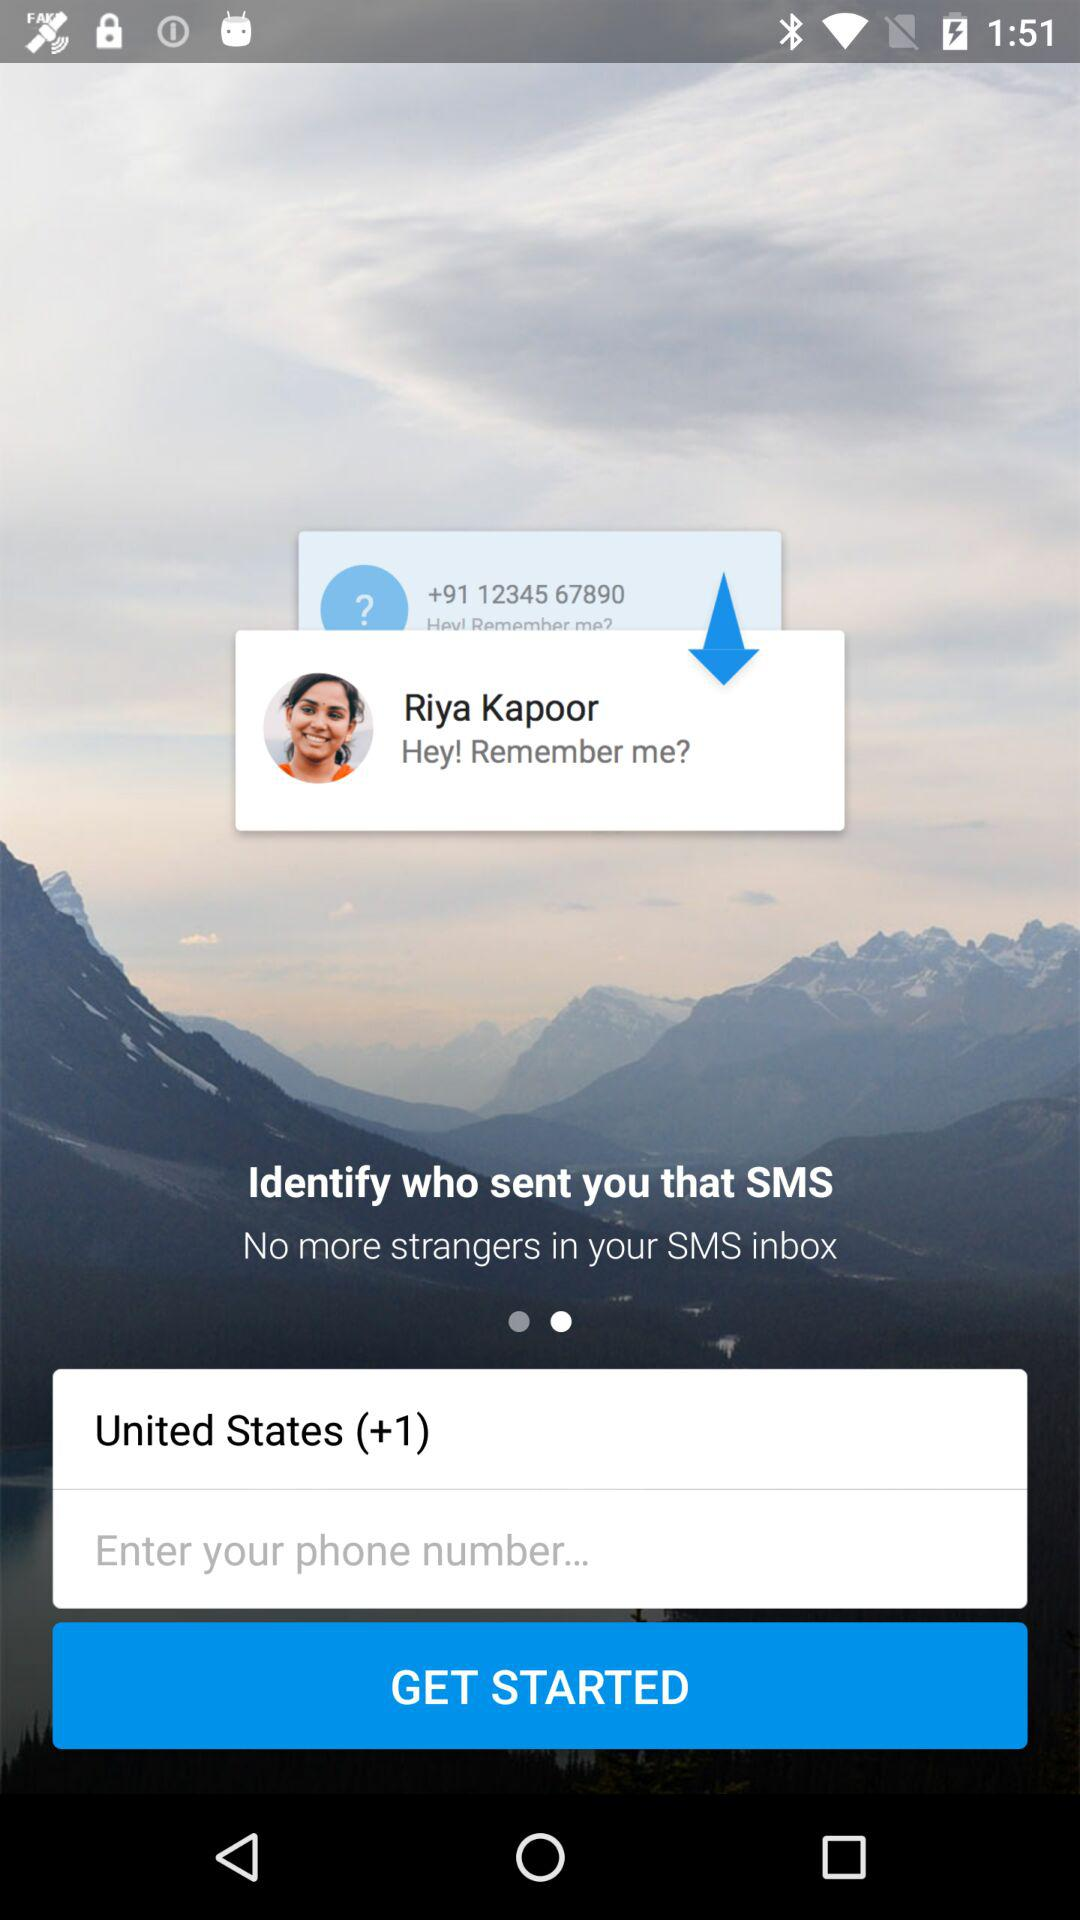What is the entered phone number?
When the provided information is insufficient, respond with <no answer>. <no answer> 